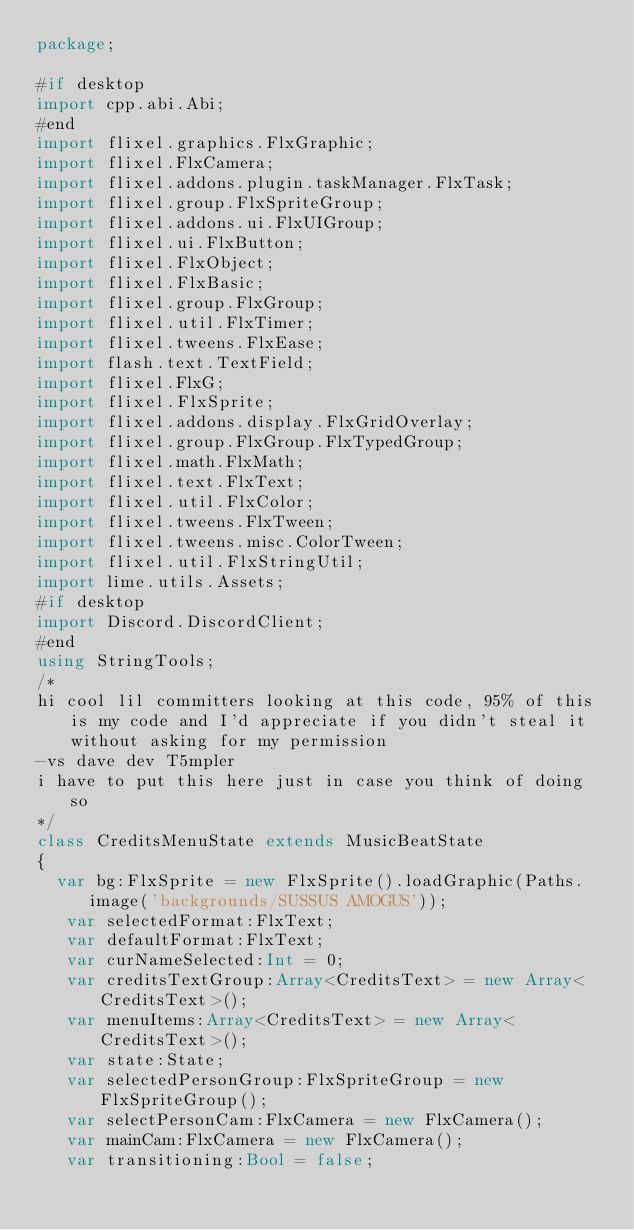<code> <loc_0><loc_0><loc_500><loc_500><_Haxe_>package;

#if desktop
import cpp.abi.Abi;
#end
import flixel.graphics.FlxGraphic;
import flixel.FlxCamera;
import flixel.addons.plugin.taskManager.FlxTask;
import flixel.group.FlxSpriteGroup;
import flixel.addons.ui.FlxUIGroup;
import flixel.ui.FlxButton;
import flixel.FlxObject;
import flixel.FlxBasic;
import flixel.group.FlxGroup;
import flixel.util.FlxTimer;
import flixel.tweens.FlxEase;
import flash.text.TextField;
import flixel.FlxG;
import flixel.FlxSprite;
import flixel.addons.display.FlxGridOverlay;
import flixel.group.FlxGroup.FlxTypedGroup;
import flixel.math.FlxMath;
import flixel.text.FlxText;
import flixel.util.FlxColor;
import flixel.tweens.FlxTween;
import flixel.tweens.misc.ColorTween;
import flixel.util.FlxStringUtil;
import lime.utils.Assets;
#if desktop
import Discord.DiscordClient;
#end
using StringTools;
/*
hi cool lil committers looking at this code, 95% of this is my code and I'd appreciate if you didn't steal it without asking for my permission
-vs dave dev T5mpler 
i have to put this here just in case you think of doing so
*/
class CreditsMenuState extends MusicBeatState
{
	var bg:FlxSprite = new FlxSprite().loadGraphic(Paths.image('backgrounds/SUSSUS AMOGUS'));
   var selectedFormat:FlxText;
   var defaultFormat:FlxText;
   var curNameSelected:Int = 0;
   var creditsTextGroup:Array<CreditsText> = new Array<CreditsText>();
   var menuItems:Array<CreditsText> = new Array<CreditsText>();
   var state:State;
   var selectedPersonGroup:FlxSpriteGroup = new FlxSpriteGroup();
   var selectPersonCam:FlxCamera = new FlxCamera();
   var mainCam:FlxCamera = new FlxCamera();
   var transitioning:Bool = false;
</code> 